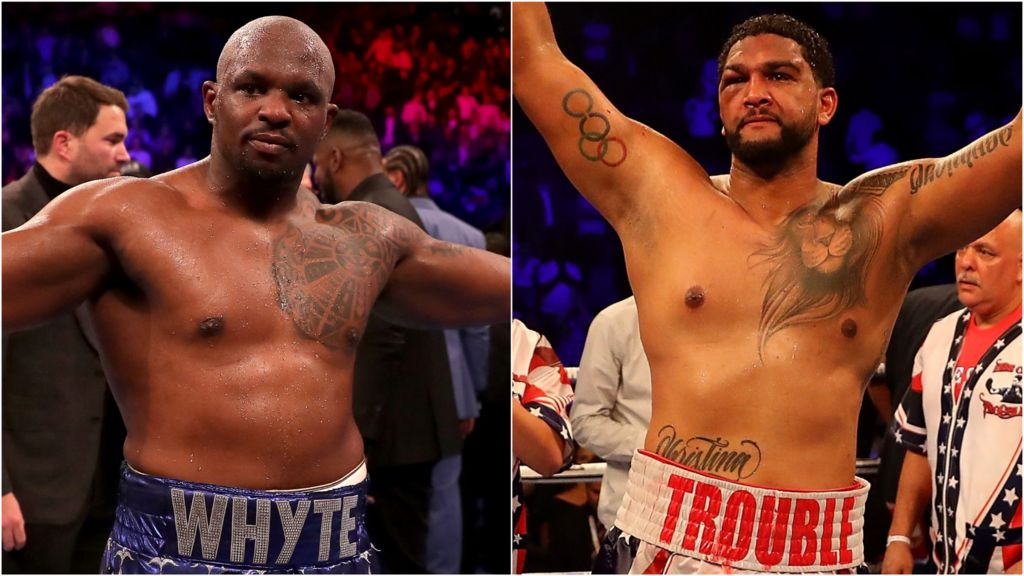Imagine the boxers are characters in a fantasy world. What roles or titles would their tattoos and physiques suggest they hold? In a fantasy world, the boxers could be envisioned as legendary warriors or champions with titles and roles deeply intertwined with their tattoos and physiques. The boxer on the left might be known as 'The Guardian of Stone,' his body etched with tattoos that are ancient runes of protection and strength, making him the ultimate fortress in battle. His well-defined muscles would speak of a lifetime dedicated to perfecting combat arts, and his aura of confidence would make him the leader of a battalion, respected and feared by all. The boxer on the right could be 'The Lionhearted,' a gallant hero endowed with the ferocity and courage symbolized by his lion tattoo. His Olympic rings could be mystical symbols of his trials and triumphs, granting him near-superhuman prowess in the arena and respect amongst his peers as an undefeated champion. Together, they would be revered as the ultimate protectors of their realm, their stories sung by bards and etched in the annals of history. 